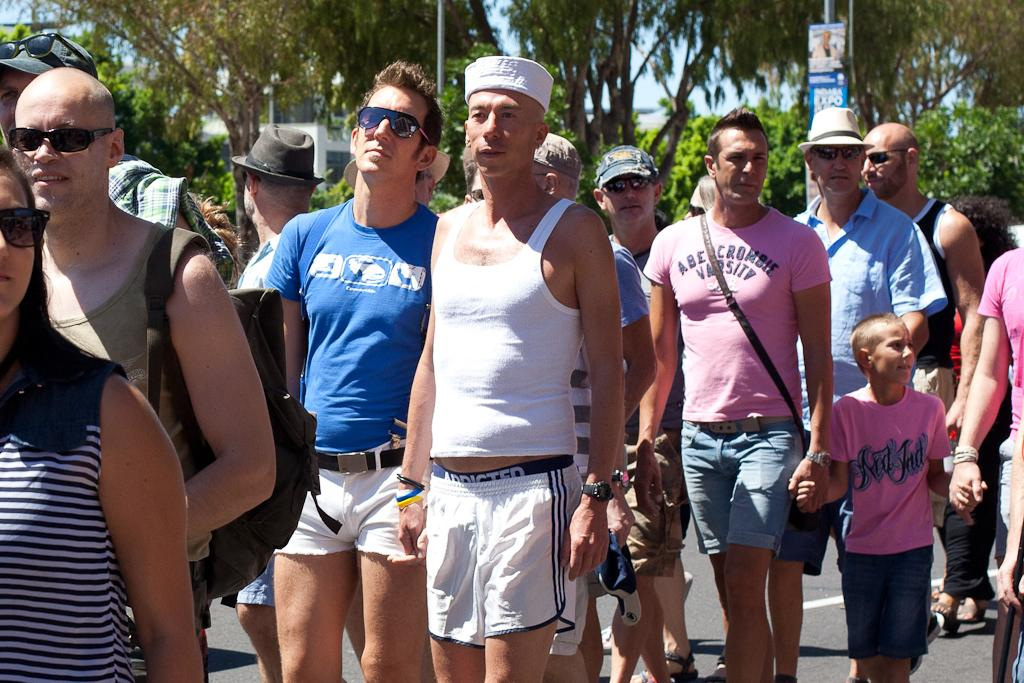What are the people in the image doing? There is a group of persons standing on the road in the image. What can be seen in the background of the image? There is a pole, a building, trees, and the sky visible in the background of the image. What type of bed can be seen in the image? There is no bed present in the image. Are there any cobwebs visible in the image? There are no cobwebs visible in the image. 